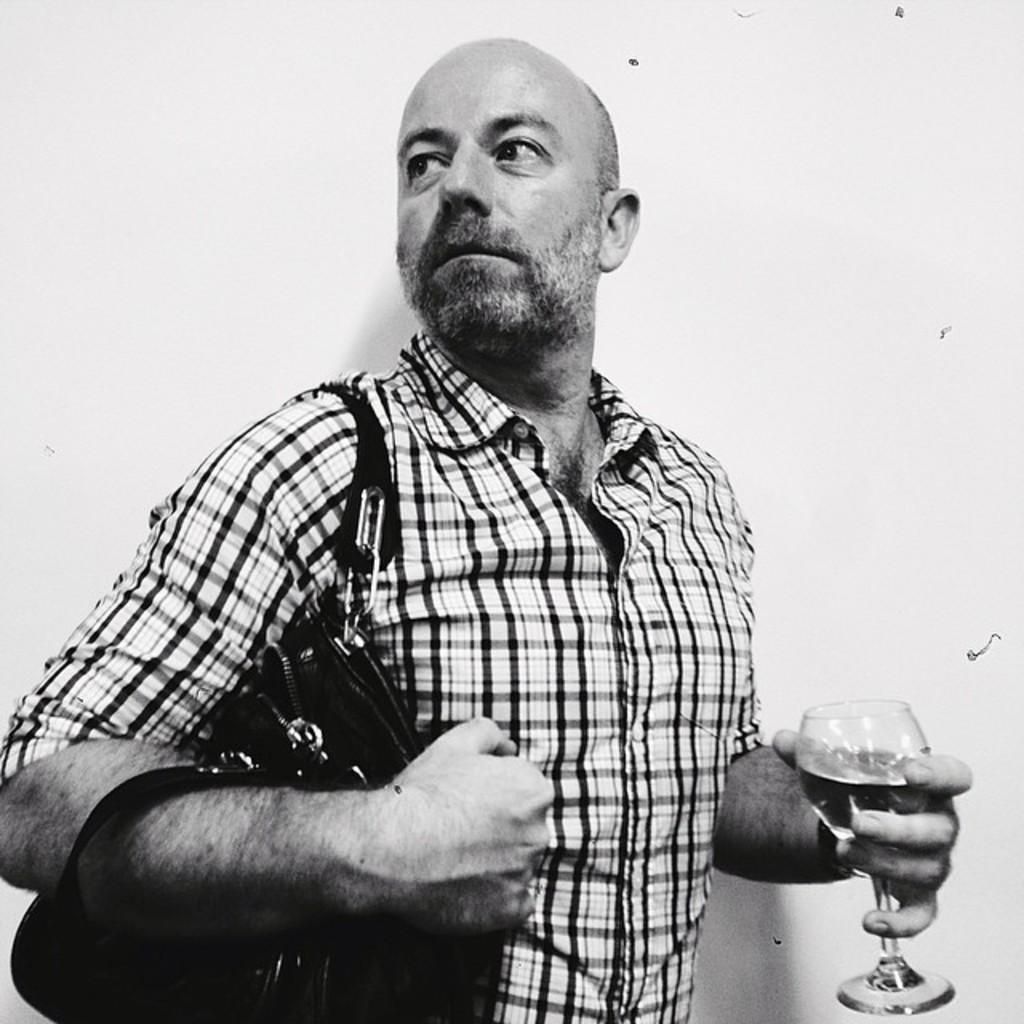What is the main subject of the image? The main subject of the image is a man. Can you describe the man's clothing in the image? The man is wearing a check shirt in the image. What is the man holding in his hands? The man is holding a handbag and a wine glass in his hands. How many pickles are on the man's plate in the image? There is no plate or pickles present in the image. What is the amount of geese flying in the background of the image? There are no geese or background visible in the image. 